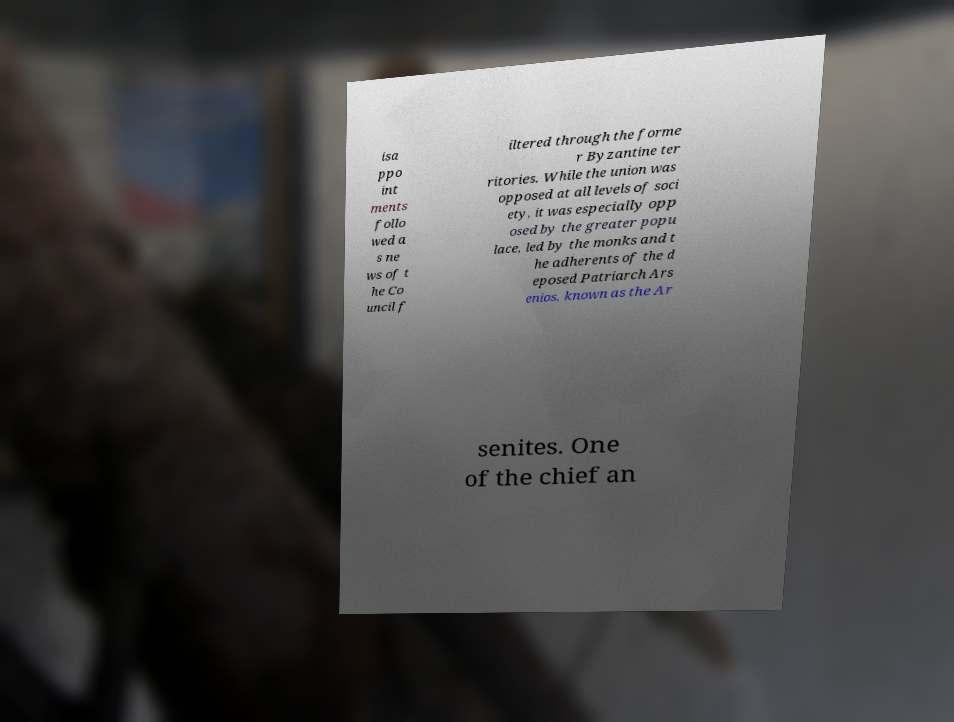There's text embedded in this image that I need extracted. Can you transcribe it verbatim? isa ppo int ments follo wed a s ne ws of t he Co uncil f iltered through the forme r Byzantine ter ritories. While the union was opposed at all levels of soci ety, it was especially opp osed by the greater popu lace, led by the monks and t he adherents of the d eposed Patriarch Ars enios, known as the Ar senites. One of the chief an 